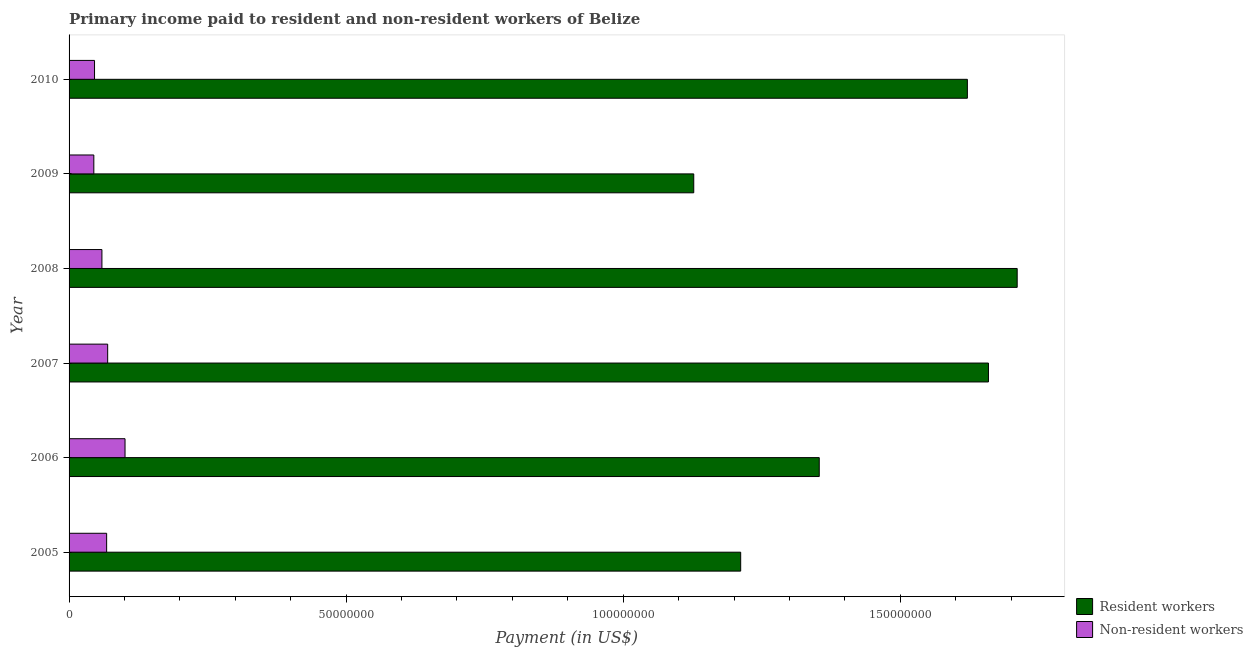Are the number of bars per tick equal to the number of legend labels?
Provide a short and direct response. Yes. How many bars are there on the 4th tick from the bottom?
Your answer should be very brief. 2. In how many cases, is the number of bars for a given year not equal to the number of legend labels?
Your answer should be very brief. 0. What is the payment made to non-resident workers in 2010?
Your answer should be compact. 4.59e+06. Across all years, what is the maximum payment made to resident workers?
Keep it short and to the point. 1.71e+08. Across all years, what is the minimum payment made to resident workers?
Provide a succinct answer. 1.13e+08. What is the total payment made to non-resident workers in the graph?
Your answer should be very brief. 3.88e+07. What is the difference between the payment made to resident workers in 2005 and that in 2010?
Give a very brief answer. -4.09e+07. What is the difference between the payment made to resident workers in 2008 and the payment made to non-resident workers in 2007?
Your answer should be very brief. 1.64e+08. What is the average payment made to resident workers per year?
Make the answer very short. 1.45e+08. In the year 2005, what is the difference between the payment made to resident workers and payment made to non-resident workers?
Give a very brief answer. 1.14e+08. In how many years, is the payment made to resident workers greater than 70000000 US$?
Your response must be concise. 6. What is the ratio of the payment made to resident workers in 2008 to that in 2010?
Your response must be concise. 1.05. What is the difference between the highest and the second highest payment made to non-resident workers?
Give a very brief answer. 3.13e+06. What is the difference between the highest and the lowest payment made to resident workers?
Provide a short and direct response. 5.84e+07. What does the 2nd bar from the top in 2008 represents?
Provide a succinct answer. Resident workers. What does the 2nd bar from the bottom in 2009 represents?
Your answer should be very brief. Non-resident workers. How many bars are there?
Offer a terse response. 12. Are all the bars in the graph horizontal?
Your response must be concise. Yes. How many years are there in the graph?
Offer a terse response. 6. Are the values on the major ticks of X-axis written in scientific E-notation?
Give a very brief answer. No. Does the graph contain grids?
Ensure brevity in your answer.  No. Where does the legend appear in the graph?
Provide a short and direct response. Bottom right. What is the title of the graph?
Offer a very short reply. Primary income paid to resident and non-resident workers of Belize. What is the label or title of the X-axis?
Offer a terse response. Payment (in US$). What is the Payment (in US$) in Resident workers in 2005?
Give a very brief answer. 1.21e+08. What is the Payment (in US$) of Non-resident workers in 2005?
Your response must be concise. 6.78e+06. What is the Payment (in US$) of Resident workers in 2006?
Ensure brevity in your answer.  1.35e+08. What is the Payment (in US$) of Non-resident workers in 2006?
Your answer should be very brief. 1.01e+07. What is the Payment (in US$) of Resident workers in 2007?
Provide a short and direct response. 1.66e+08. What is the Payment (in US$) in Non-resident workers in 2007?
Your answer should be compact. 6.97e+06. What is the Payment (in US$) in Resident workers in 2008?
Make the answer very short. 1.71e+08. What is the Payment (in US$) of Non-resident workers in 2008?
Your answer should be compact. 5.93e+06. What is the Payment (in US$) in Resident workers in 2009?
Ensure brevity in your answer.  1.13e+08. What is the Payment (in US$) in Non-resident workers in 2009?
Make the answer very short. 4.47e+06. What is the Payment (in US$) of Resident workers in 2010?
Provide a succinct answer. 1.62e+08. What is the Payment (in US$) in Non-resident workers in 2010?
Provide a succinct answer. 4.59e+06. Across all years, what is the maximum Payment (in US$) of Resident workers?
Offer a very short reply. 1.71e+08. Across all years, what is the maximum Payment (in US$) of Non-resident workers?
Your answer should be compact. 1.01e+07. Across all years, what is the minimum Payment (in US$) in Resident workers?
Provide a succinct answer. 1.13e+08. Across all years, what is the minimum Payment (in US$) of Non-resident workers?
Your response must be concise. 4.47e+06. What is the total Payment (in US$) of Resident workers in the graph?
Your answer should be compact. 8.68e+08. What is the total Payment (in US$) in Non-resident workers in the graph?
Offer a very short reply. 3.88e+07. What is the difference between the Payment (in US$) of Resident workers in 2005 and that in 2006?
Provide a succinct answer. -1.42e+07. What is the difference between the Payment (in US$) of Non-resident workers in 2005 and that in 2006?
Your answer should be compact. -3.32e+06. What is the difference between the Payment (in US$) in Resident workers in 2005 and that in 2007?
Give a very brief answer. -4.47e+07. What is the difference between the Payment (in US$) of Non-resident workers in 2005 and that in 2007?
Your response must be concise. -1.86e+05. What is the difference between the Payment (in US$) of Resident workers in 2005 and that in 2008?
Offer a very short reply. -4.99e+07. What is the difference between the Payment (in US$) in Non-resident workers in 2005 and that in 2008?
Provide a succinct answer. 8.54e+05. What is the difference between the Payment (in US$) in Resident workers in 2005 and that in 2009?
Keep it short and to the point. 8.47e+06. What is the difference between the Payment (in US$) of Non-resident workers in 2005 and that in 2009?
Your response must be concise. 2.31e+06. What is the difference between the Payment (in US$) of Resident workers in 2005 and that in 2010?
Give a very brief answer. -4.09e+07. What is the difference between the Payment (in US$) of Non-resident workers in 2005 and that in 2010?
Your answer should be very brief. 2.19e+06. What is the difference between the Payment (in US$) in Resident workers in 2006 and that in 2007?
Keep it short and to the point. -3.05e+07. What is the difference between the Payment (in US$) of Non-resident workers in 2006 and that in 2007?
Your response must be concise. 3.13e+06. What is the difference between the Payment (in US$) in Resident workers in 2006 and that in 2008?
Keep it short and to the point. -3.57e+07. What is the difference between the Payment (in US$) of Non-resident workers in 2006 and that in 2008?
Ensure brevity in your answer.  4.17e+06. What is the difference between the Payment (in US$) in Resident workers in 2006 and that in 2009?
Ensure brevity in your answer.  2.26e+07. What is the difference between the Payment (in US$) in Non-resident workers in 2006 and that in 2009?
Make the answer very short. 5.63e+06. What is the difference between the Payment (in US$) in Resident workers in 2006 and that in 2010?
Provide a short and direct response. -2.67e+07. What is the difference between the Payment (in US$) in Non-resident workers in 2006 and that in 2010?
Make the answer very short. 5.51e+06. What is the difference between the Payment (in US$) of Resident workers in 2007 and that in 2008?
Make the answer very short. -5.19e+06. What is the difference between the Payment (in US$) in Non-resident workers in 2007 and that in 2008?
Your response must be concise. 1.04e+06. What is the difference between the Payment (in US$) in Resident workers in 2007 and that in 2009?
Offer a terse response. 5.32e+07. What is the difference between the Payment (in US$) of Non-resident workers in 2007 and that in 2009?
Your answer should be compact. 2.50e+06. What is the difference between the Payment (in US$) in Resident workers in 2007 and that in 2010?
Ensure brevity in your answer.  3.80e+06. What is the difference between the Payment (in US$) in Non-resident workers in 2007 and that in 2010?
Provide a short and direct response. 2.37e+06. What is the difference between the Payment (in US$) of Resident workers in 2008 and that in 2009?
Give a very brief answer. 5.84e+07. What is the difference between the Payment (in US$) of Non-resident workers in 2008 and that in 2009?
Your answer should be very brief. 1.46e+06. What is the difference between the Payment (in US$) in Resident workers in 2008 and that in 2010?
Your response must be concise. 8.99e+06. What is the difference between the Payment (in US$) in Non-resident workers in 2008 and that in 2010?
Keep it short and to the point. 1.33e+06. What is the difference between the Payment (in US$) of Resident workers in 2009 and that in 2010?
Offer a terse response. -4.94e+07. What is the difference between the Payment (in US$) in Non-resident workers in 2009 and that in 2010?
Your response must be concise. -1.27e+05. What is the difference between the Payment (in US$) in Resident workers in 2005 and the Payment (in US$) in Non-resident workers in 2006?
Offer a terse response. 1.11e+08. What is the difference between the Payment (in US$) of Resident workers in 2005 and the Payment (in US$) of Non-resident workers in 2007?
Offer a terse response. 1.14e+08. What is the difference between the Payment (in US$) in Resident workers in 2005 and the Payment (in US$) in Non-resident workers in 2008?
Offer a terse response. 1.15e+08. What is the difference between the Payment (in US$) of Resident workers in 2005 and the Payment (in US$) of Non-resident workers in 2009?
Provide a succinct answer. 1.17e+08. What is the difference between the Payment (in US$) in Resident workers in 2005 and the Payment (in US$) in Non-resident workers in 2010?
Make the answer very short. 1.17e+08. What is the difference between the Payment (in US$) of Resident workers in 2006 and the Payment (in US$) of Non-resident workers in 2007?
Your answer should be very brief. 1.28e+08. What is the difference between the Payment (in US$) of Resident workers in 2006 and the Payment (in US$) of Non-resident workers in 2008?
Provide a short and direct response. 1.29e+08. What is the difference between the Payment (in US$) in Resident workers in 2006 and the Payment (in US$) in Non-resident workers in 2009?
Provide a short and direct response. 1.31e+08. What is the difference between the Payment (in US$) of Resident workers in 2006 and the Payment (in US$) of Non-resident workers in 2010?
Offer a very short reply. 1.31e+08. What is the difference between the Payment (in US$) of Resident workers in 2007 and the Payment (in US$) of Non-resident workers in 2008?
Keep it short and to the point. 1.60e+08. What is the difference between the Payment (in US$) in Resident workers in 2007 and the Payment (in US$) in Non-resident workers in 2009?
Offer a very short reply. 1.61e+08. What is the difference between the Payment (in US$) of Resident workers in 2007 and the Payment (in US$) of Non-resident workers in 2010?
Your answer should be very brief. 1.61e+08. What is the difference between the Payment (in US$) of Resident workers in 2008 and the Payment (in US$) of Non-resident workers in 2009?
Ensure brevity in your answer.  1.67e+08. What is the difference between the Payment (in US$) of Resident workers in 2008 and the Payment (in US$) of Non-resident workers in 2010?
Your response must be concise. 1.67e+08. What is the difference between the Payment (in US$) of Resident workers in 2009 and the Payment (in US$) of Non-resident workers in 2010?
Give a very brief answer. 1.08e+08. What is the average Payment (in US$) in Resident workers per year?
Ensure brevity in your answer.  1.45e+08. What is the average Payment (in US$) of Non-resident workers per year?
Make the answer very short. 6.47e+06. In the year 2005, what is the difference between the Payment (in US$) of Resident workers and Payment (in US$) of Non-resident workers?
Keep it short and to the point. 1.14e+08. In the year 2006, what is the difference between the Payment (in US$) in Resident workers and Payment (in US$) in Non-resident workers?
Your response must be concise. 1.25e+08. In the year 2007, what is the difference between the Payment (in US$) in Resident workers and Payment (in US$) in Non-resident workers?
Give a very brief answer. 1.59e+08. In the year 2008, what is the difference between the Payment (in US$) of Resident workers and Payment (in US$) of Non-resident workers?
Give a very brief answer. 1.65e+08. In the year 2009, what is the difference between the Payment (in US$) of Resident workers and Payment (in US$) of Non-resident workers?
Your answer should be very brief. 1.08e+08. In the year 2010, what is the difference between the Payment (in US$) of Resident workers and Payment (in US$) of Non-resident workers?
Give a very brief answer. 1.58e+08. What is the ratio of the Payment (in US$) of Resident workers in 2005 to that in 2006?
Your response must be concise. 0.9. What is the ratio of the Payment (in US$) of Non-resident workers in 2005 to that in 2006?
Provide a short and direct response. 0.67. What is the ratio of the Payment (in US$) in Resident workers in 2005 to that in 2007?
Make the answer very short. 0.73. What is the ratio of the Payment (in US$) of Non-resident workers in 2005 to that in 2007?
Offer a very short reply. 0.97. What is the ratio of the Payment (in US$) of Resident workers in 2005 to that in 2008?
Give a very brief answer. 0.71. What is the ratio of the Payment (in US$) of Non-resident workers in 2005 to that in 2008?
Make the answer very short. 1.14. What is the ratio of the Payment (in US$) in Resident workers in 2005 to that in 2009?
Offer a very short reply. 1.08. What is the ratio of the Payment (in US$) of Non-resident workers in 2005 to that in 2009?
Your answer should be compact. 1.52. What is the ratio of the Payment (in US$) in Resident workers in 2005 to that in 2010?
Offer a terse response. 0.75. What is the ratio of the Payment (in US$) in Non-resident workers in 2005 to that in 2010?
Provide a succinct answer. 1.48. What is the ratio of the Payment (in US$) in Resident workers in 2006 to that in 2007?
Your answer should be very brief. 0.82. What is the ratio of the Payment (in US$) of Non-resident workers in 2006 to that in 2007?
Provide a short and direct response. 1.45. What is the ratio of the Payment (in US$) of Resident workers in 2006 to that in 2008?
Your answer should be very brief. 0.79. What is the ratio of the Payment (in US$) of Non-resident workers in 2006 to that in 2008?
Ensure brevity in your answer.  1.7. What is the ratio of the Payment (in US$) of Resident workers in 2006 to that in 2009?
Keep it short and to the point. 1.2. What is the ratio of the Payment (in US$) in Non-resident workers in 2006 to that in 2009?
Keep it short and to the point. 2.26. What is the ratio of the Payment (in US$) in Resident workers in 2006 to that in 2010?
Your answer should be compact. 0.84. What is the ratio of the Payment (in US$) in Non-resident workers in 2006 to that in 2010?
Provide a short and direct response. 2.2. What is the ratio of the Payment (in US$) of Resident workers in 2007 to that in 2008?
Give a very brief answer. 0.97. What is the ratio of the Payment (in US$) of Non-resident workers in 2007 to that in 2008?
Provide a succinct answer. 1.18. What is the ratio of the Payment (in US$) in Resident workers in 2007 to that in 2009?
Give a very brief answer. 1.47. What is the ratio of the Payment (in US$) of Non-resident workers in 2007 to that in 2009?
Provide a short and direct response. 1.56. What is the ratio of the Payment (in US$) of Resident workers in 2007 to that in 2010?
Provide a short and direct response. 1.02. What is the ratio of the Payment (in US$) of Non-resident workers in 2007 to that in 2010?
Ensure brevity in your answer.  1.52. What is the ratio of the Payment (in US$) in Resident workers in 2008 to that in 2009?
Your response must be concise. 1.52. What is the ratio of the Payment (in US$) in Non-resident workers in 2008 to that in 2009?
Your answer should be compact. 1.33. What is the ratio of the Payment (in US$) in Resident workers in 2008 to that in 2010?
Your response must be concise. 1.06. What is the ratio of the Payment (in US$) in Non-resident workers in 2008 to that in 2010?
Ensure brevity in your answer.  1.29. What is the ratio of the Payment (in US$) in Resident workers in 2009 to that in 2010?
Offer a terse response. 0.7. What is the ratio of the Payment (in US$) in Non-resident workers in 2009 to that in 2010?
Offer a very short reply. 0.97. What is the difference between the highest and the second highest Payment (in US$) in Resident workers?
Offer a terse response. 5.19e+06. What is the difference between the highest and the second highest Payment (in US$) in Non-resident workers?
Keep it short and to the point. 3.13e+06. What is the difference between the highest and the lowest Payment (in US$) of Resident workers?
Offer a very short reply. 5.84e+07. What is the difference between the highest and the lowest Payment (in US$) of Non-resident workers?
Your answer should be very brief. 5.63e+06. 